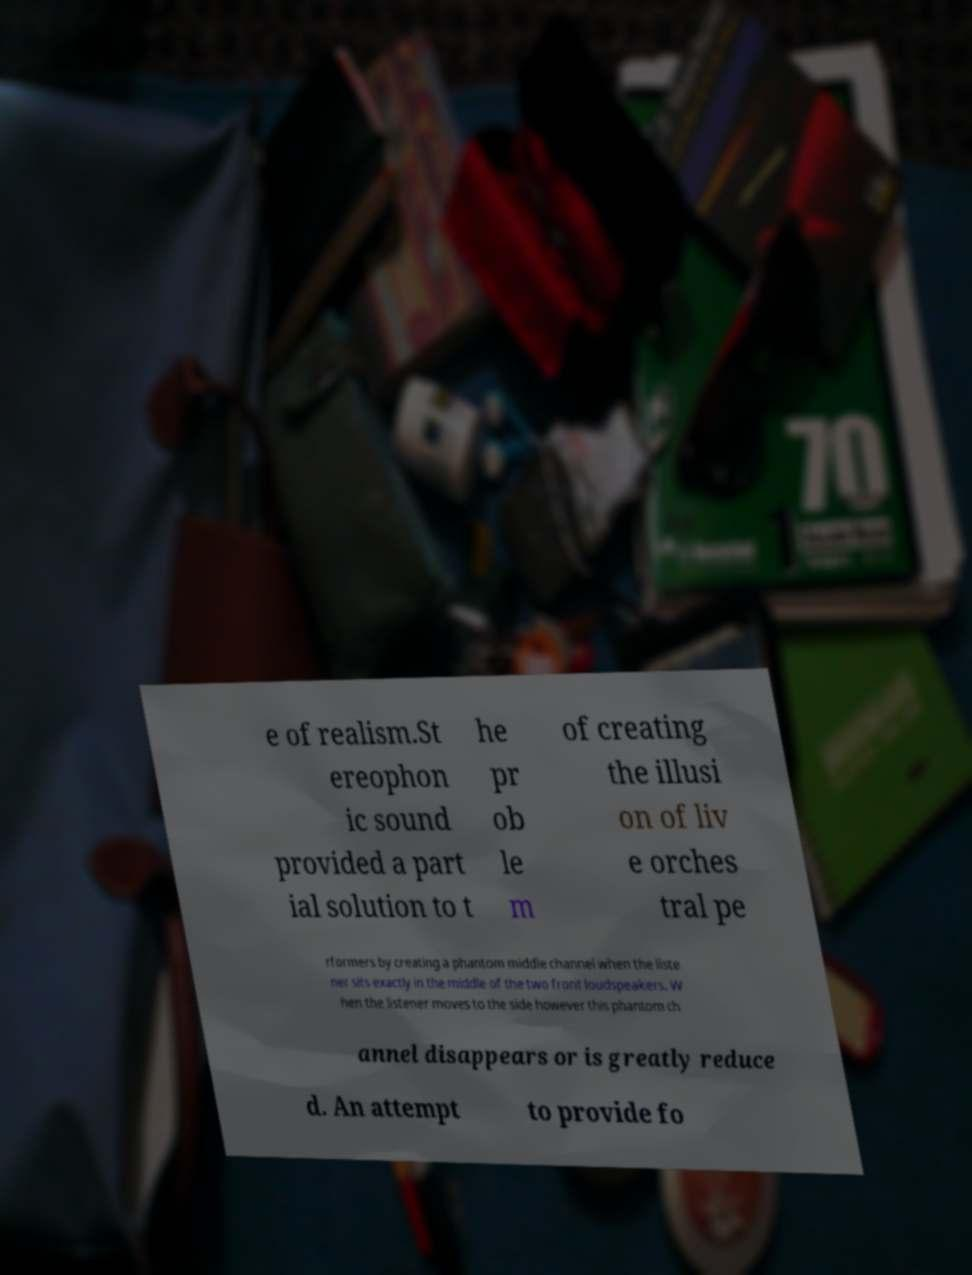What messages or text are displayed in this image? I need them in a readable, typed format. e of realism.St ereophon ic sound provided a part ial solution to t he pr ob le m of creating the illusi on of liv e orches tral pe rformers by creating a phantom middle channel when the liste ner sits exactly in the middle of the two front loudspeakers. W hen the listener moves to the side however this phantom ch annel disappears or is greatly reduce d. An attempt to provide fo 